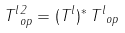Convert formula to latex. <formula><loc_0><loc_0><loc_500><loc_500>\| T ^ { l } \| _ { o p } ^ { 2 } = \| ( T ^ { l } ) ^ { * } \, T ^ { l } \| _ { o p }</formula> 